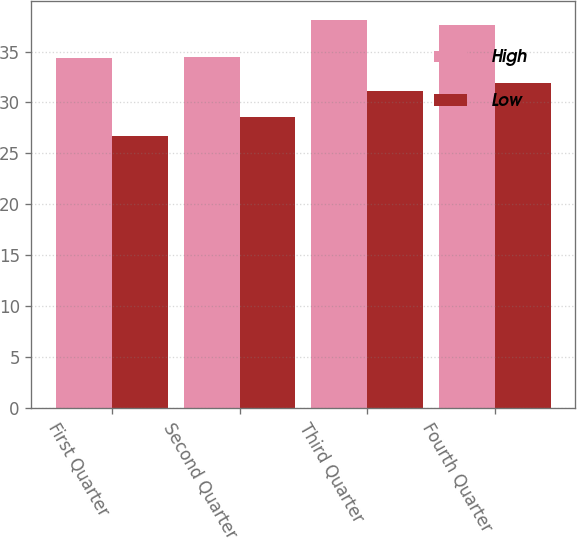Convert chart. <chart><loc_0><loc_0><loc_500><loc_500><stacked_bar_chart><ecel><fcel>First Quarter<fcel>Second Quarter<fcel>Third Quarter<fcel>Fourth Quarter<nl><fcel>High<fcel>34.37<fcel>34.5<fcel>38.05<fcel>37.65<nl><fcel>Low<fcel>26.7<fcel>28.53<fcel>31.08<fcel>31.87<nl></chart> 